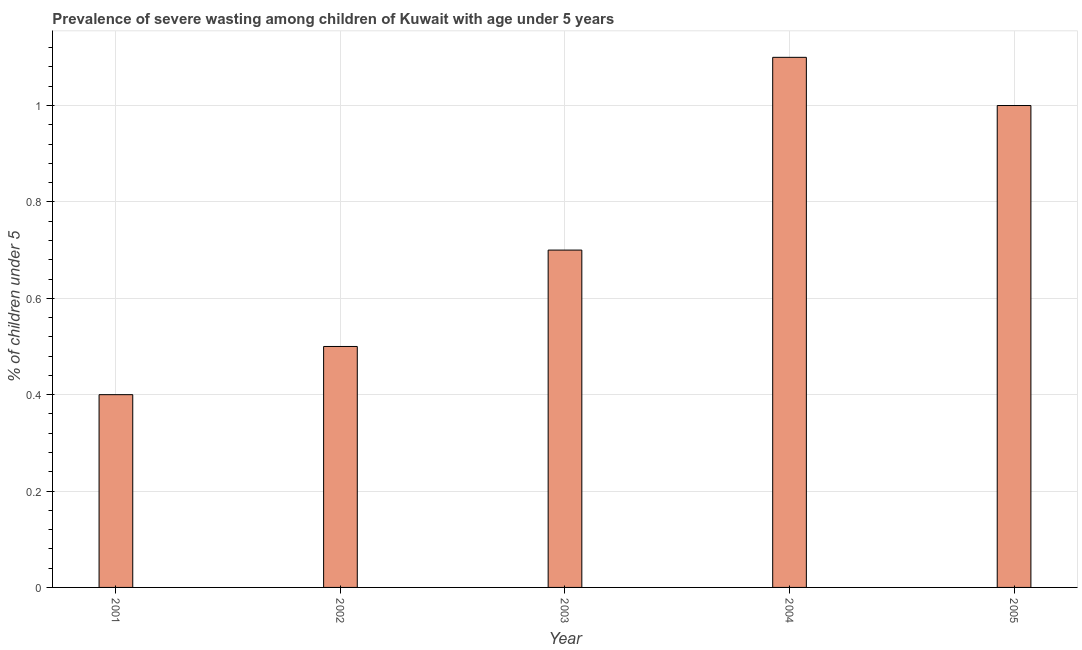Does the graph contain any zero values?
Provide a short and direct response. No. What is the title of the graph?
Your response must be concise. Prevalence of severe wasting among children of Kuwait with age under 5 years. What is the label or title of the Y-axis?
Your response must be concise.  % of children under 5. What is the prevalence of severe wasting in 2003?
Ensure brevity in your answer.  0.7. Across all years, what is the maximum prevalence of severe wasting?
Give a very brief answer. 1.1. Across all years, what is the minimum prevalence of severe wasting?
Offer a terse response. 0.4. What is the sum of the prevalence of severe wasting?
Keep it short and to the point. 3.7. What is the difference between the prevalence of severe wasting in 2003 and 2004?
Make the answer very short. -0.4. What is the average prevalence of severe wasting per year?
Offer a terse response. 0.74. What is the median prevalence of severe wasting?
Your answer should be compact. 0.7. In how many years, is the prevalence of severe wasting greater than 0.96 %?
Provide a short and direct response. 2. Is the difference between the prevalence of severe wasting in 2001 and 2005 greater than the difference between any two years?
Provide a short and direct response. No. Is the sum of the prevalence of severe wasting in 2004 and 2005 greater than the maximum prevalence of severe wasting across all years?
Your answer should be very brief. Yes. What is the difference between the highest and the lowest prevalence of severe wasting?
Give a very brief answer. 0.7. How many bars are there?
Offer a very short reply. 5. How many years are there in the graph?
Make the answer very short. 5. What is the difference between two consecutive major ticks on the Y-axis?
Your answer should be very brief. 0.2. What is the  % of children under 5 in 2001?
Provide a short and direct response. 0.4. What is the  % of children under 5 of 2003?
Your answer should be very brief. 0.7. What is the  % of children under 5 in 2004?
Give a very brief answer. 1.1. What is the difference between the  % of children under 5 in 2001 and 2002?
Ensure brevity in your answer.  -0.1. What is the difference between the  % of children under 5 in 2001 and 2003?
Give a very brief answer. -0.3. What is the difference between the  % of children under 5 in 2001 and 2004?
Give a very brief answer. -0.7. What is the difference between the  % of children under 5 in 2001 and 2005?
Keep it short and to the point. -0.6. What is the difference between the  % of children under 5 in 2002 and 2004?
Provide a succinct answer. -0.6. What is the difference between the  % of children under 5 in 2002 and 2005?
Your answer should be very brief. -0.5. What is the difference between the  % of children under 5 in 2003 and 2004?
Keep it short and to the point. -0.4. What is the difference between the  % of children under 5 in 2003 and 2005?
Offer a very short reply. -0.3. What is the ratio of the  % of children under 5 in 2001 to that in 2002?
Offer a very short reply. 0.8. What is the ratio of the  % of children under 5 in 2001 to that in 2003?
Make the answer very short. 0.57. What is the ratio of the  % of children under 5 in 2001 to that in 2004?
Offer a very short reply. 0.36. What is the ratio of the  % of children under 5 in 2002 to that in 2003?
Keep it short and to the point. 0.71. What is the ratio of the  % of children under 5 in 2002 to that in 2004?
Keep it short and to the point. 0.46. What is the ratio of the  % of children under 5 in 2002 to that in 2005?
Your response must be concise. 0.5. What is the ratio of the  % of children under 5 in 2003 to that in 2004?
Your response must be concise. 0.64. 